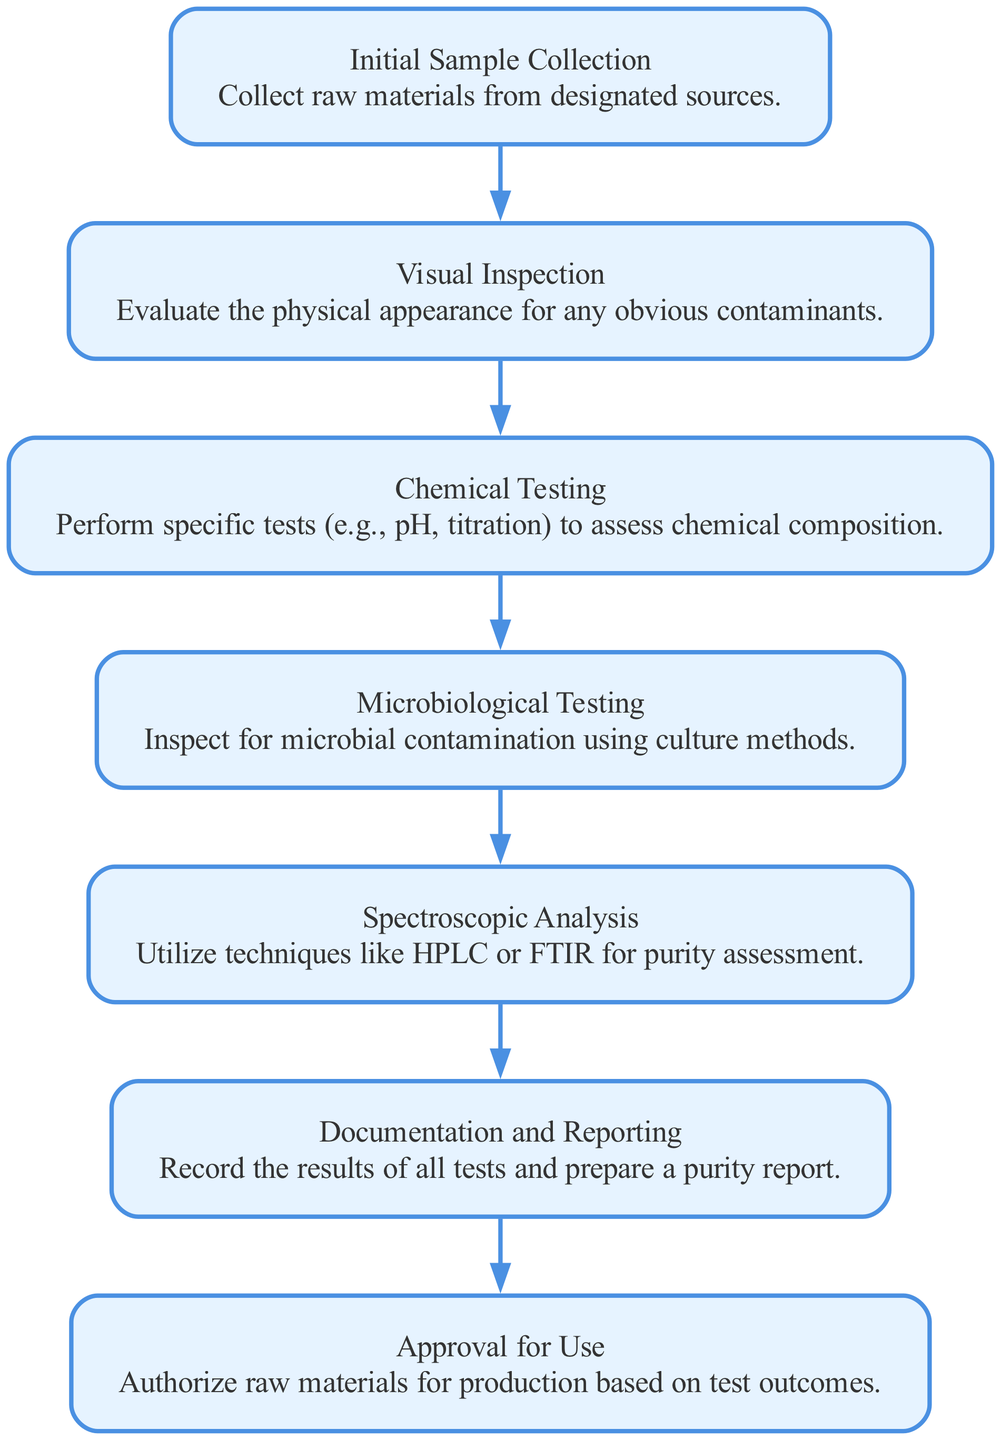What is the first step in the purity verification process? The first step, as indicated in the flow chart, is "Initial Sample Collection." This is where raw materials are collected from designated sources before any testing begins.
Answer: Initial Sample Collection How many total steps are there in the purity verification process? By counting the nodes in the flow chart, we can see there are seven distinct steps listed in the process.
Answer: Seven Which step follows "Visual Inspection"? In the flow chart, the step that immediately follows "Visual Inspection" is "Chemical Testing." This shows the progression from evaluating the physical appearance to assessing the chemical composition.
Answer: Chemical Testing What type of testing is performed after "Microbiological Testing"? According to the flow chart, after "Microbiological Testing," the next step is "Spectroscopic Analysis." This indicates that tests for microbial contamination are followed by advanced purity assessment techniques.
Answer: Spectroscopic Analysis What is the last step of the purity verification process? The last step, as per the flow diagram, is "Approval for Use." This signifies that after all testing and documentation, the raw materials can be authorized for production if they meet the required standards.
Answer: Approval for Use What are the two types of tests conducted before "Documentation and Reporting"? The steps just before "Documentation and Reporting" are "Spectroscopic Analysis" and "Microbiological Testing." This shows that both advanced purity tests and microbial checks must be completed prior to documentation.
Answer: Spectroscopic Analysis and Microbiological Testing How does "Chemical Testing" relate to "Visual Inspection" in terms of process flow? In the flow chart, "Chemical Testing" directly follows "Visual Inspection." This demonstrates that after the physical inspection, chemical analysis is necessary to further validate the substance's purity before proceeding to microbiological checks.
Answer: Chemical Testing follows Visual Inspection Please list all the types of tests conducted in the purity verification process. The types of tests mentioned in the flow chart are "Chemical Testing," "Microbiological Testing," and "Spectroscopic Analysis." Listing them helps in understanding the various methodologies used for assessing substance purity.
Answer: Chemical Testing, Microbiological Testing, Spectroscopic Analysis 